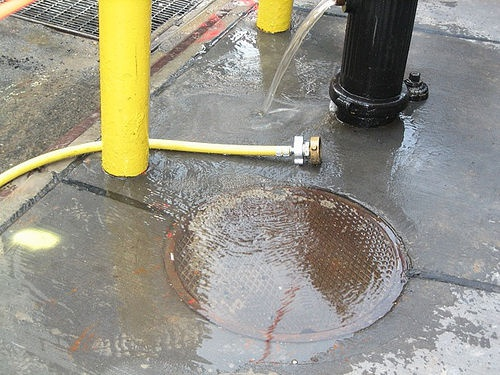Describe the objects in this image and their specific colors. I can see a fire hydrant in gray, black, darkgray, and lightgray tones in this image. 